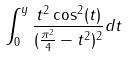<formula> <loc_0><loc_0><loc_500><loc_500>\int _ { 0 } ^ { y } \frac { t ^ { 2 } \cos ^ { 2 } ( t ) } { ( \frac { \pi ^ { 2 } } { 4 } - t ^ { 2 } ) ^ { 2 } } d t</formula> 